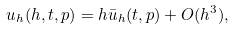<formula> <loc_0><loc_0><loc_500><loc_500>u _ { h } ( h , t , p ) = h \bar { u } _ { h } ( t , p ) + O ( h ^ { 3 } ) ,</formula> 